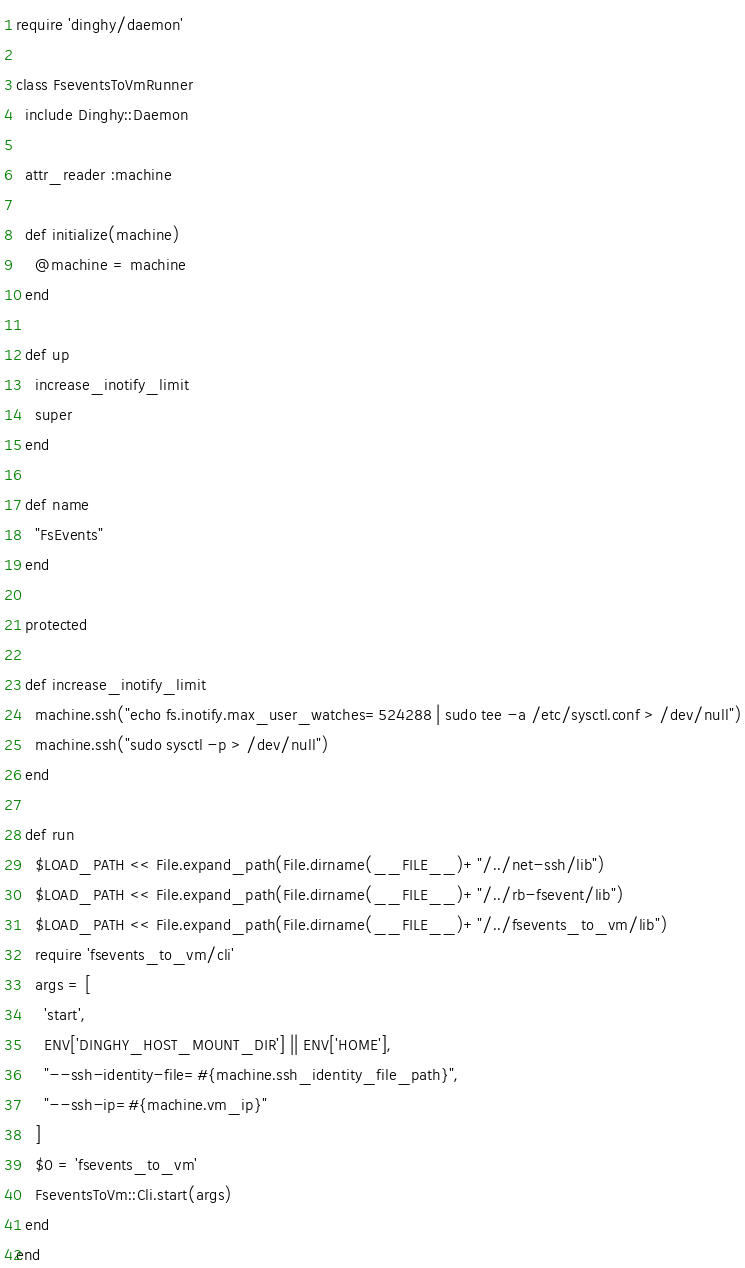<code> <loc_0><loc_0><loc_500><loc_500><_Ruby_>require 'dinghy/daemon'

class FseventsToVmRunner
  include Dinghy::Daemon

  attr_reader :machine

  def initialize(machine)
    @machine = machine
  end

  def up
    increase_inotify_limit
    super
  end

  def name
    "FsEvents"
  end

  protected

  def increase_inotify_limit
    machine.ssh("echo fs.inotify.max_user_watches=524288 | sudo tee -a /etc/sysctl.conf > /dev/null")
    machine.ssh("sudo sysctl -p > /dev/null")
  end

  def run
    $LOAD_PATH << File.expand_path(File.dirname(__FILE__)+"/../net-ssh/lib")
    $LOAD_PATH << File.expand_path(File.dirname(__FILE__)+"/../rb-fsevent/lib")
    $LOAD_PATH << File.expand_path(File.dirname(__FILE__)+"/../fsevents_to_vm/lib")
    require 'fsevents_to_vm/cli'
    args = [
      'start',
      ENV['DINGHY_HOST_MOUNT_DIR'] || ENV['HOME'],
      "--ssh-identity-file=#{machine.ssh_identity_file_path}",
      "--ssh-ip=#{machine.vm_ip}"
    ]
    $0 = 'fsevents_to_vm'
    FseventsToVm::Cli.start(args)
  end
end
</code> 